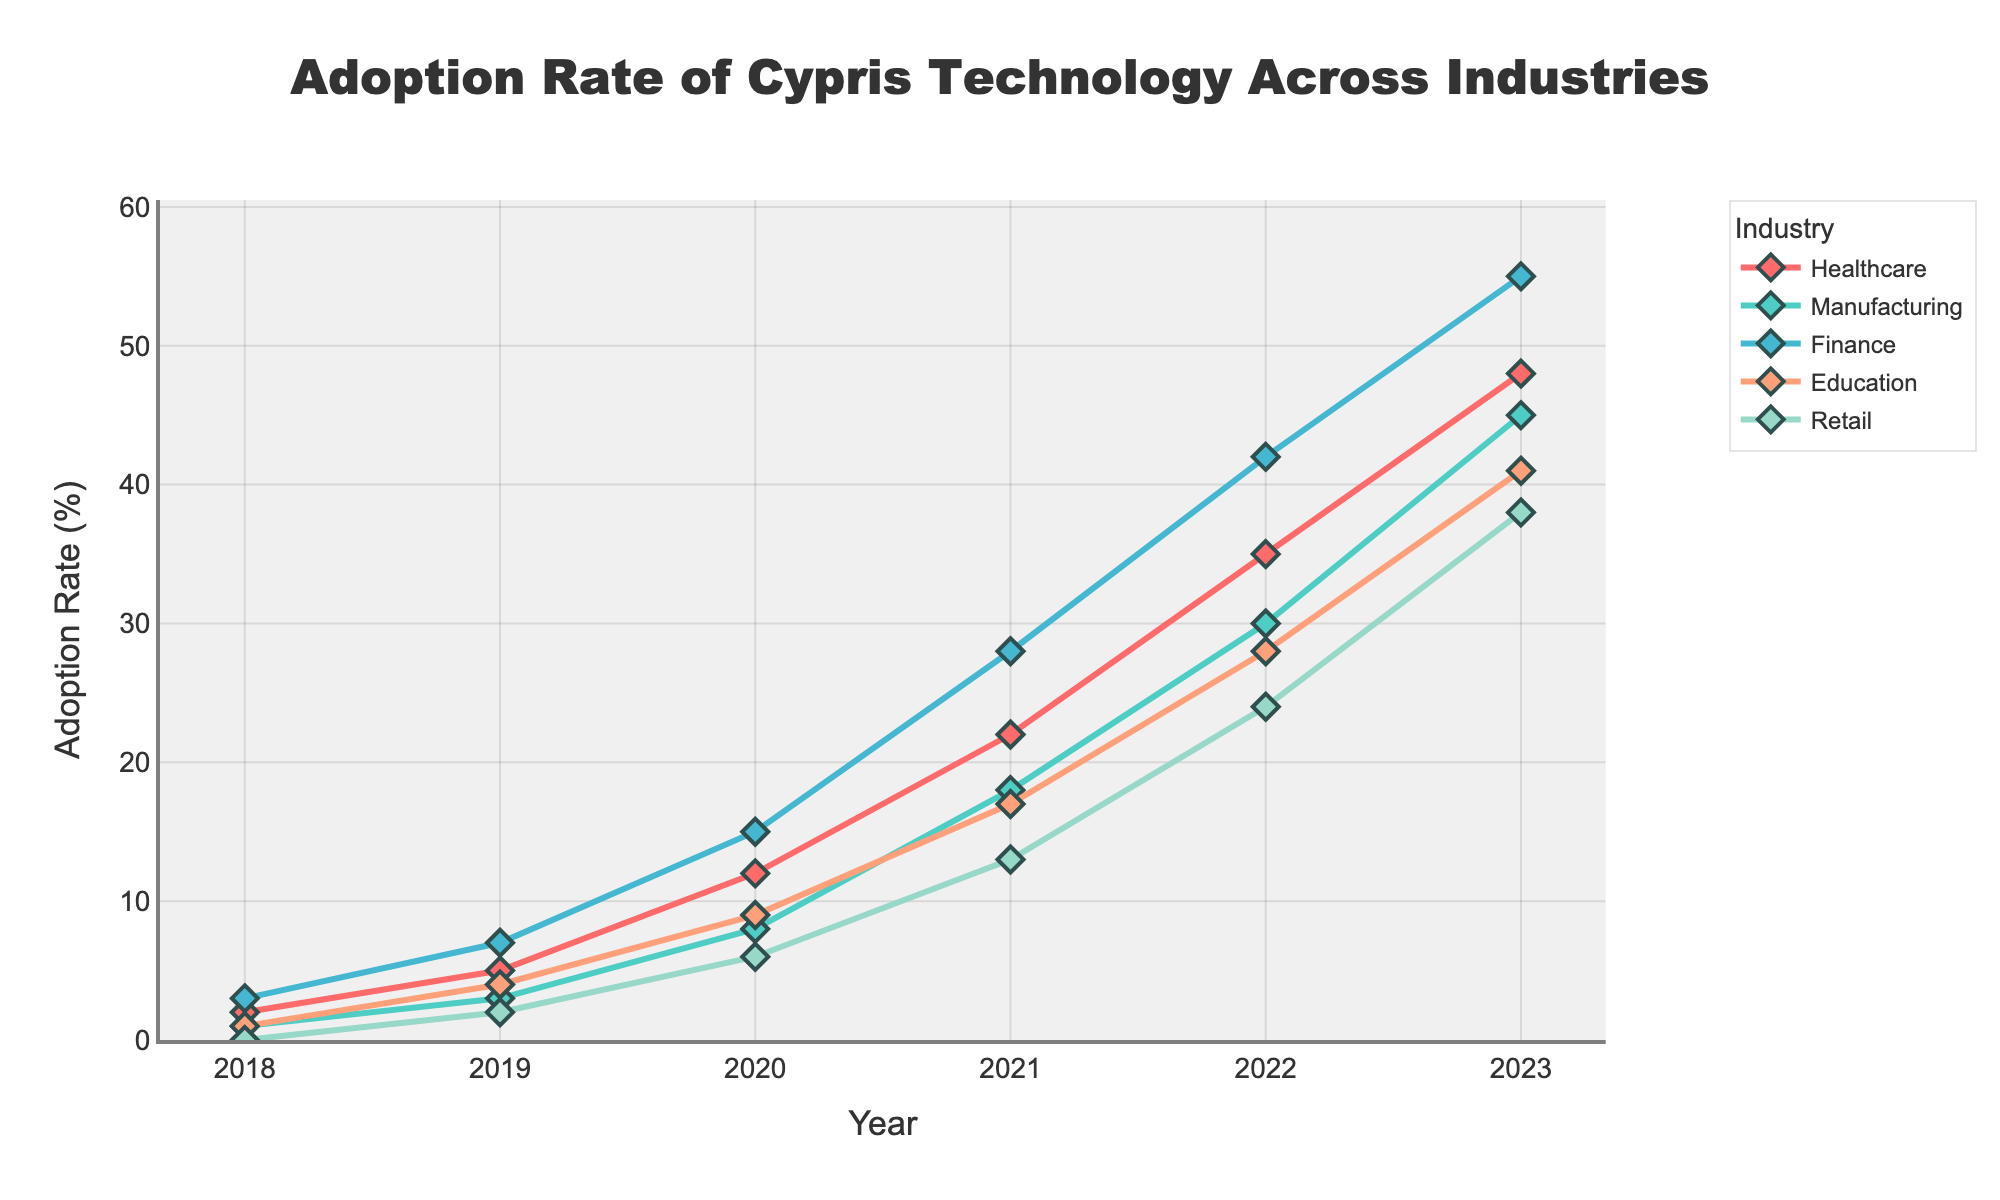Which industry had the highest adoption rate in 2023? To determine the industry with the highest adoption rate in 2023, we compare the values for Healthcare, Manufacturing, Finance, Education, and Retail. In 2023, Finance has the highest value at 55%.
Answer: Finance How did the adoption rate in Retail change from 2018 to 2020? To find the change in Retail adoption rate from 2018 to 2020, we subtract the 2018 value (0%) from the 2020 value (6%). The change is 6 - 0 = 6%.
Answer: 6% What was the average adoption rate across all industries in 2021? To find the average adoption rate, add the values for all industries in 2021 (22 + 18 + 28 + 17 + 13) and divide by the number of industries (5). The sum is 98, and the average is 98/5 = 19.6%.
Answer: 19.6% Which industry saw the largest absolute increase in adoption rate from 2021 to 2023? To determine the largest increase, calculate the differences for each industry between 2021 and 2023: Healthcare (48-22=26), Manufacturing (45-18=27), Finance (55-28=27), Education (41-17=24), and Retail (38-13=25). The largest increase is in Manufacturing and Finance, both by 27%.
Answer: Manufacturing and Finance Did any industry experience a decrease in adoption rate at any point from 2018 to 2023? By observing the plot lines for each industry from 2018 to 2023, we see that they are all continuously increasing with no decreases at any point.
Answer: No Which industry had the second-highest adoption rate in 2022, and what was the rate? To find the second-highest adoption rate in 2022, list the rates (Healthcare 35, Manufacturing 30, Finance 42, Education 28, Retail 24) and arrange them in descending order: 42, 35, 30, 28, 24. The second-highest rate is 35% from Healthcare.
Answer: Healthcare, 35% In which year did the Education industry surpass a 20% adoption rate? By looking at the line for Education, we see it surpassed 20% between 2021 and 2022 as it was 28% in 2022.
Answer: 2022 What is the sum of the adoption rates for all industries in 2019? Sum the adoption rates for each industry in 2019: 5 (Healthcare) + 3 (Manufacturing) + 7 (Finance) + 4 (Education) + 2 (Retail). This sums to 21.
Answer: 21 